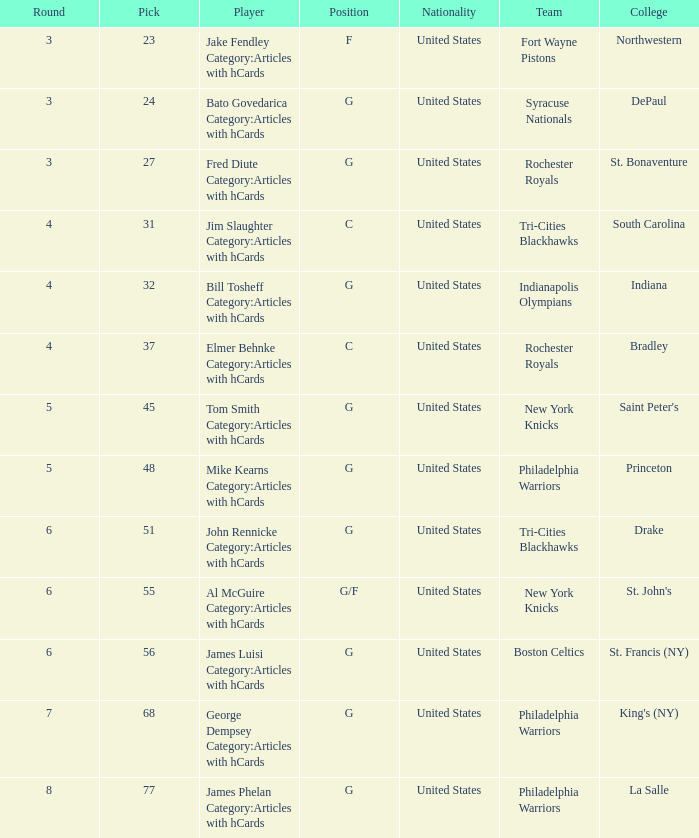What is the sum total of picks for drake players from the tri-cities blackhawks? 51.0. 